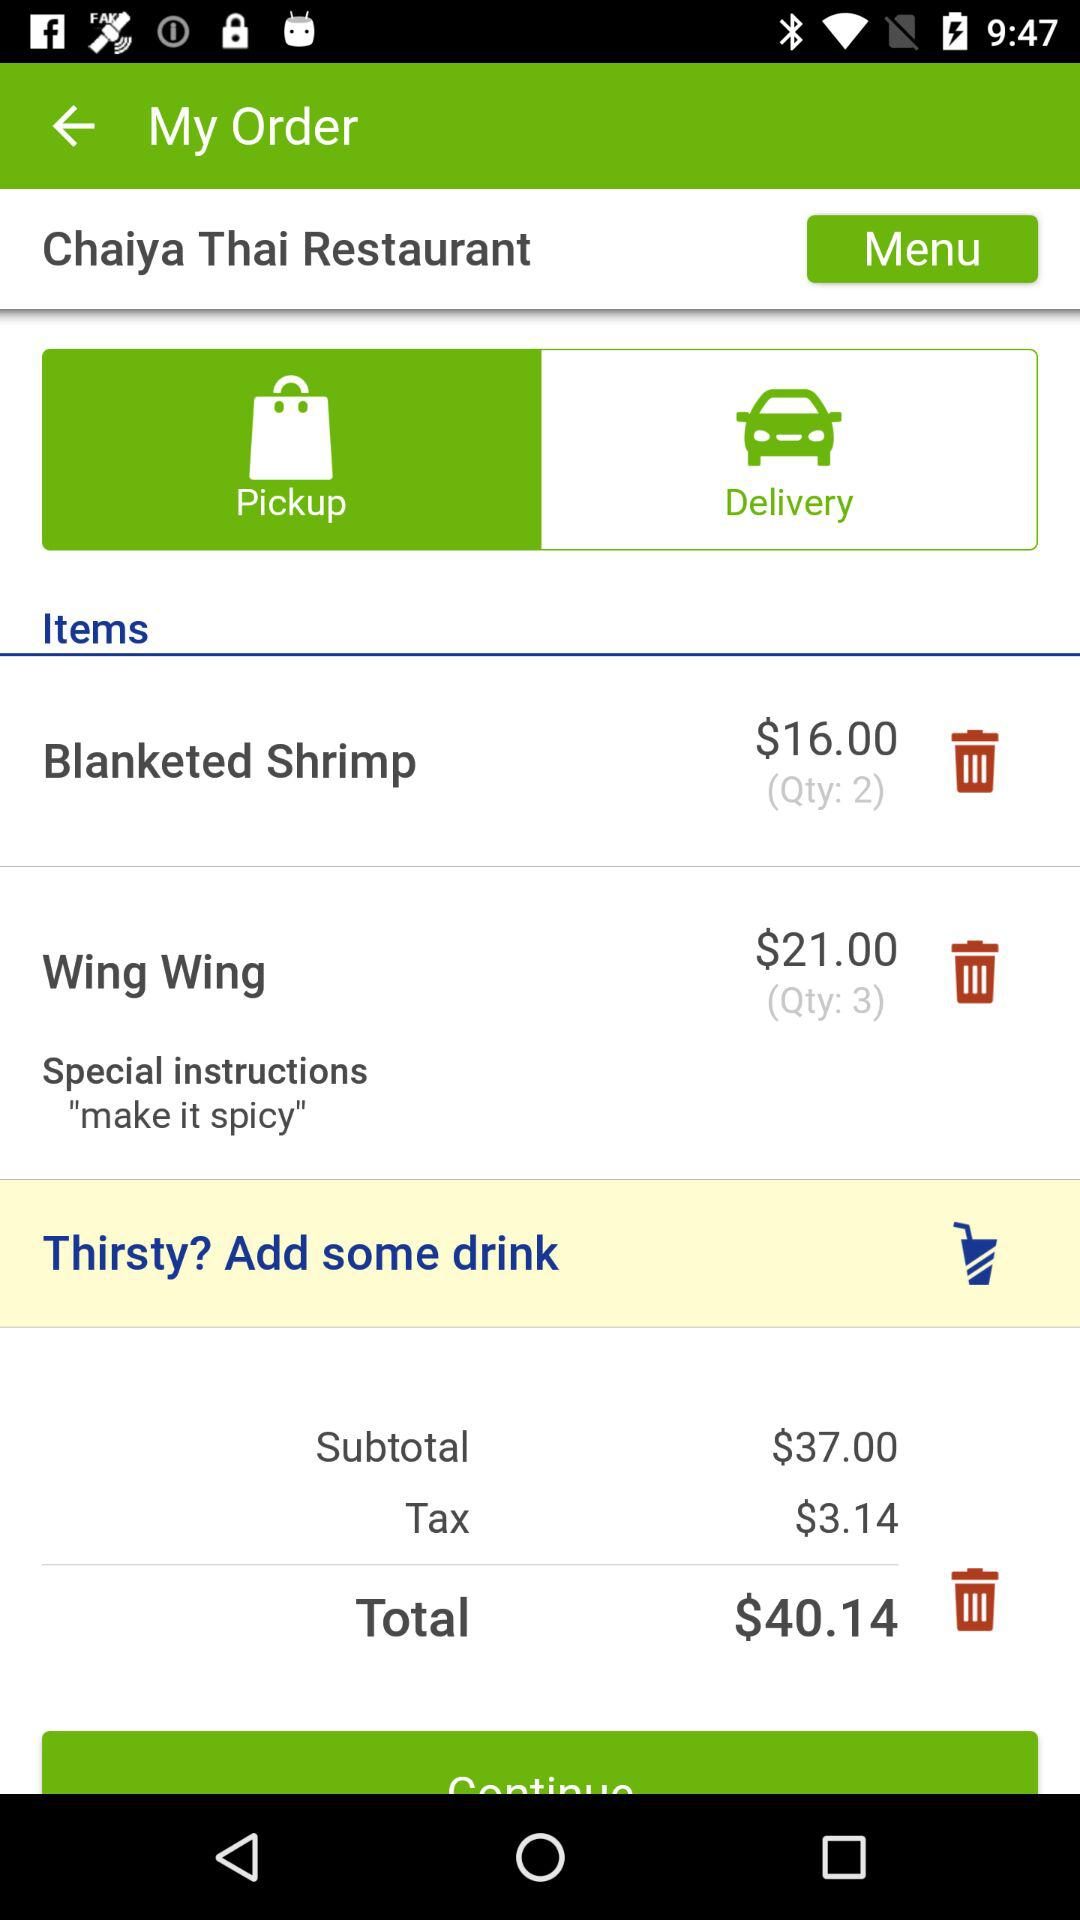How much do I need to pay for the items I've ordered?
Answer the question using a single word or phrase. $40.14 